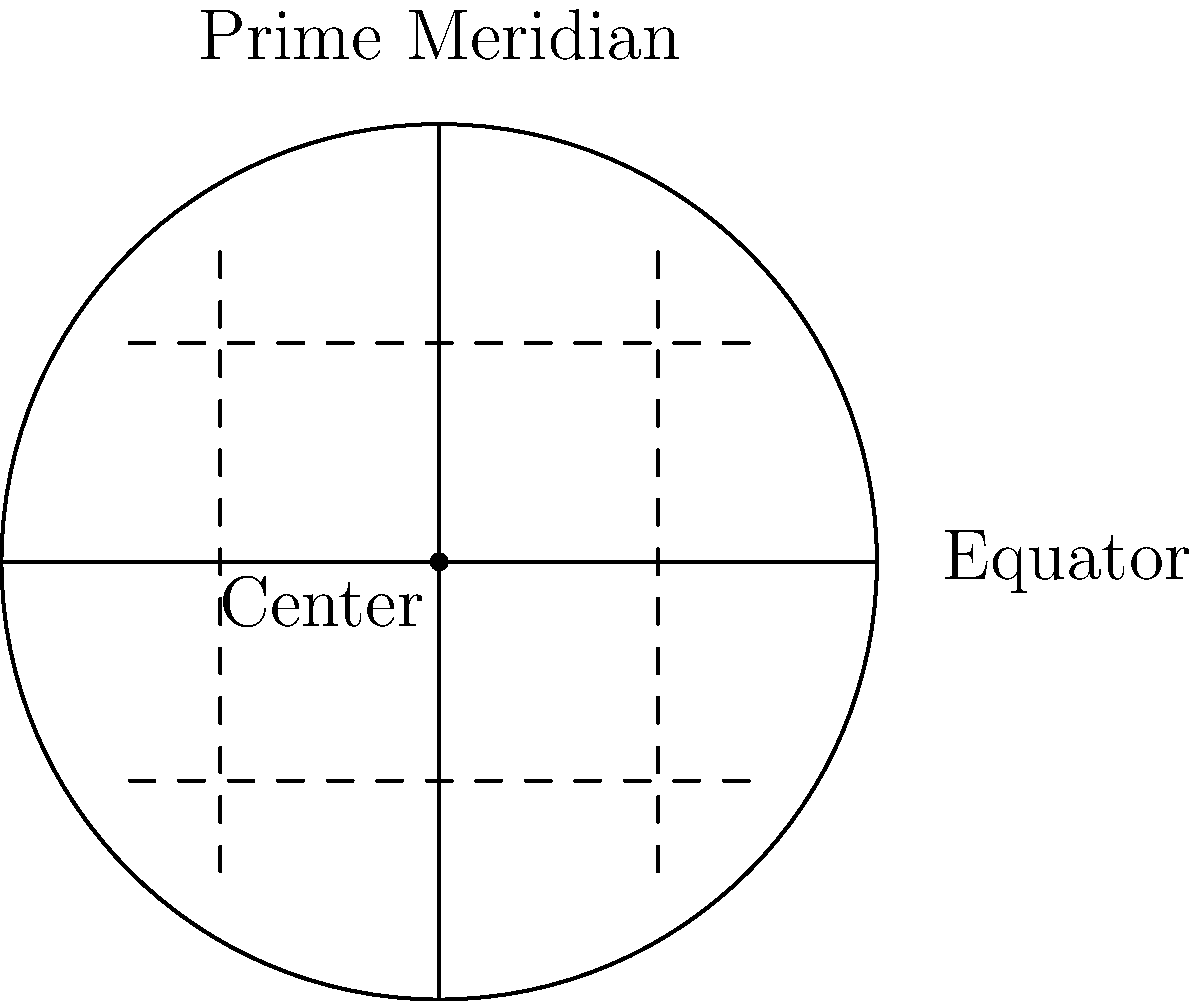In examining a historical map from 16th century China, you notice that the landmasses are represented on a circular grid with equally spaced parallel lines and meridians that curve outward from the center. Based on this information and the provided diagram, which cartographic projection is most likely used in this map? To identify the cartographic projection used in this historical Asian map, let's analyze the given information and diagram step-by-step:

1. The map is represented on a circular grid: This suggests a polar projection or a projection centered on a specific point.

2. Parallel lines are equally spaced: In many projections, parallels are not equally spaced. Equal spacing of parallels is a characteristic of equidistant projections.

3. Meridians curve outward from the center: This eliminates projections with straight meridians, such as the Mercator or Plate Carrée projections.

4. The overall circular shape with curved meridians: This is typical of azimuthal projections, which project the Earth's surface onto a plane tangent to a point on the globe.

5. Combining the equidistant property with the azimuthal characteristic: This points to the Azimuthal Equidistant projection.

6. Historical context: The Azimuthal Equidistant projection has been used in Chinese cartography since ancient times, known as the "Hu Yi" or "Barbarian Submission" map.

7. Properties of Azimuthal Equidistant projection:
   - Distances from the center point to any other point are preserved.
   - Directions from the center point are true.
   - Shape, area, and angles are distorted, especially far from the center.

8. The diagram shows:
   - A circular outline (representing the edge of the map)
   - Equally spaced parallel lines (representing latitudes)
   - Meridians curving outward from the center
   
These features are consistent with the Azimuthal Equidistant projection.

Therefore, based on the description and the diagram, the cartographic projection most likely used in this 16th-century Chinese map is the Azimuthal Equidistant projection.
Answer: Azimuthal Equidistant projection 